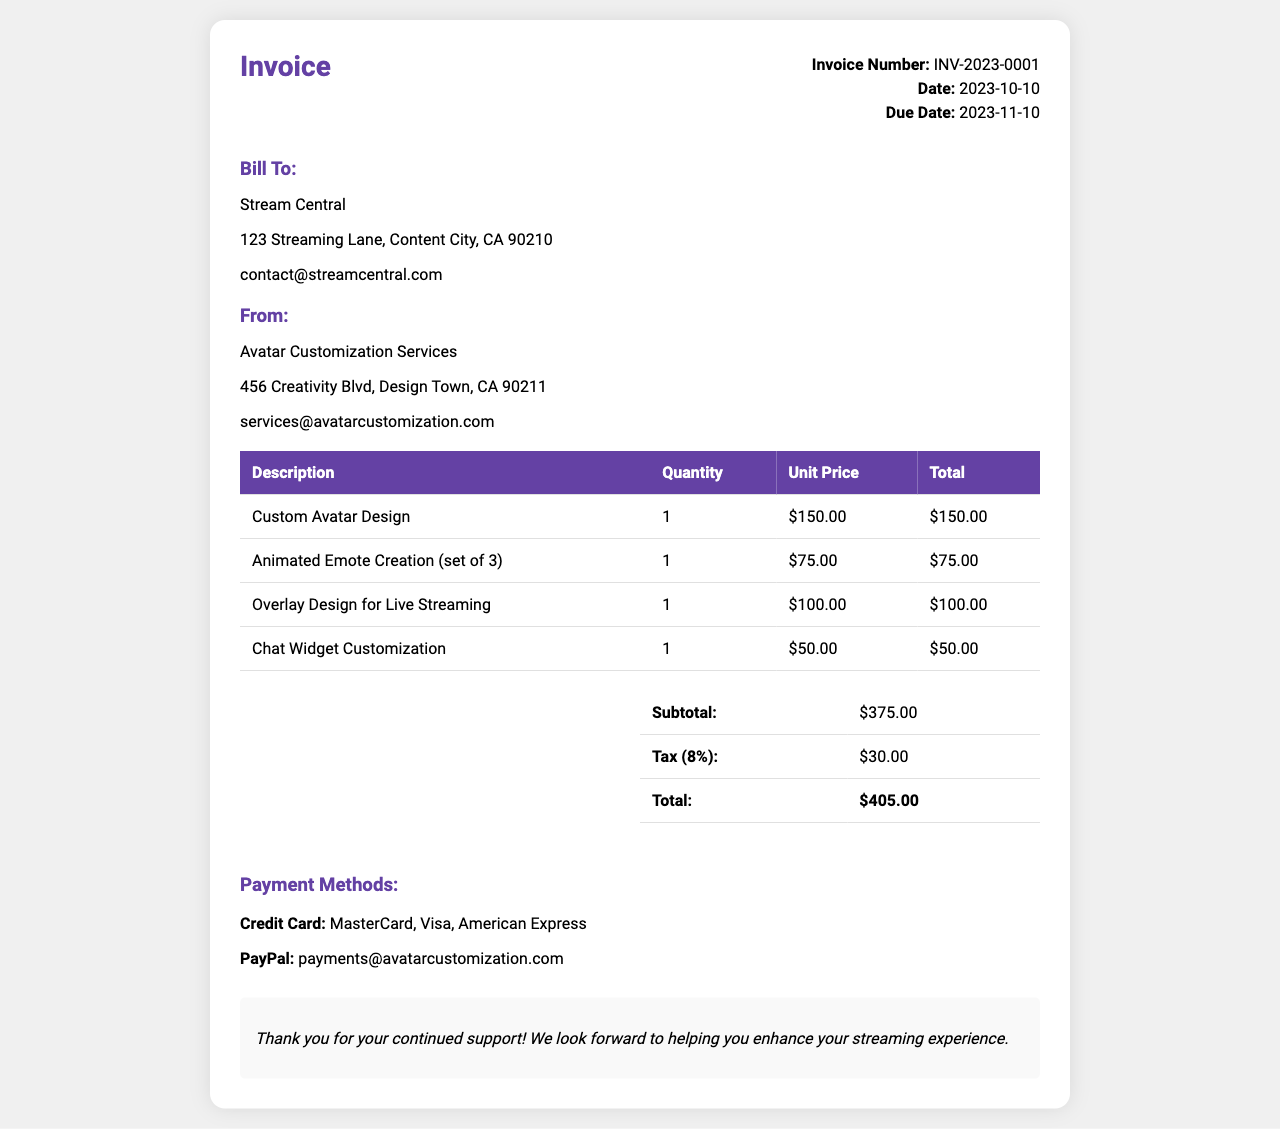what is the invoice number? The invoice number is clearly stated in the document, which is INV-2023-0001.
Answer: INV-2023-0001 what is the due date of the invoice? The due date is specified in the document as 2023-11-10.
Answer: 2023-11-10 who is billed in this invoice? The "Bill To" section identifies the recipient of the invoice, which is Stream Central.
Answer: Stream Central what is the subtotal amount? The subtotal is listed in the summary table as $375.00.
Answer: $375.00 how much is charged for the Custom Avatar Design? The document specifies the cost of the Custom Avatar Design as $150.00.
Answer: $150.00 what is the total amount including tax? The document provides the total amount, which includes tax, as $405.00.
Answer: $405.00 how many animated emotes were created? The quantity for the Animated Emote Creation is listed as 1 set of 3.
Answer: 1 what services are provided for live streaming enhancement? The services listed for live streaming enhancement include Overlay Design and Chat Widget Customization.
Answer: Overlay Design and Chat Widget Customization what payment methods are accepted? The payment methods section lists accepted methods including credit cards and PayPal.
Answer: Credit Card and PayPal 